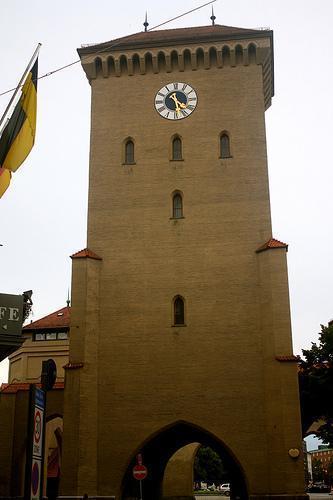How many clock towers are there?
Give a very brief answer. 1. 